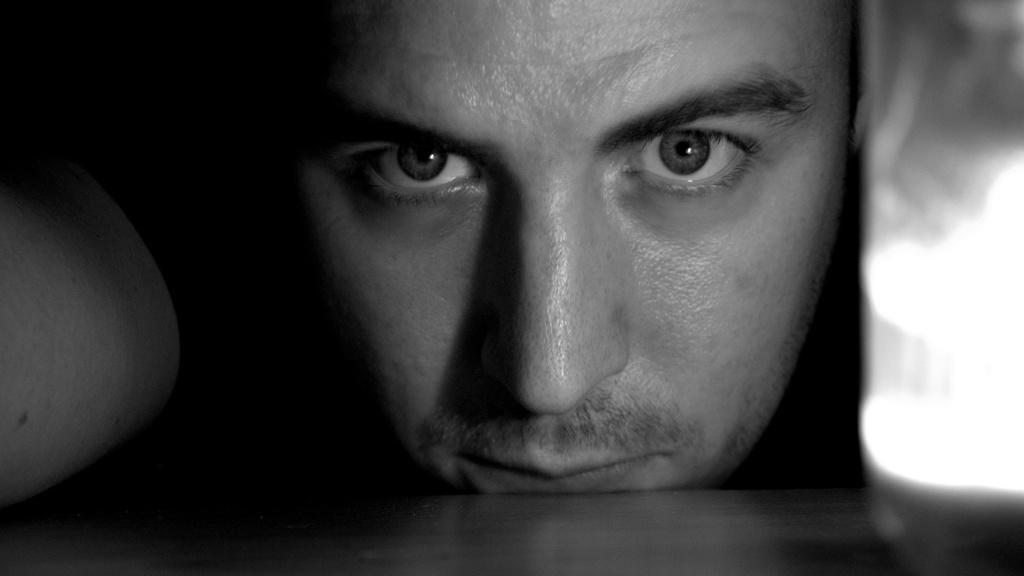In one or two sentences, can you explain what this image depicts? This is a black and white image. At the bottom there is a wooden object which seems to be a table. Behind there is a person's face. This person is looking at the picture. On the right side there is an object which seems to be a glass. 